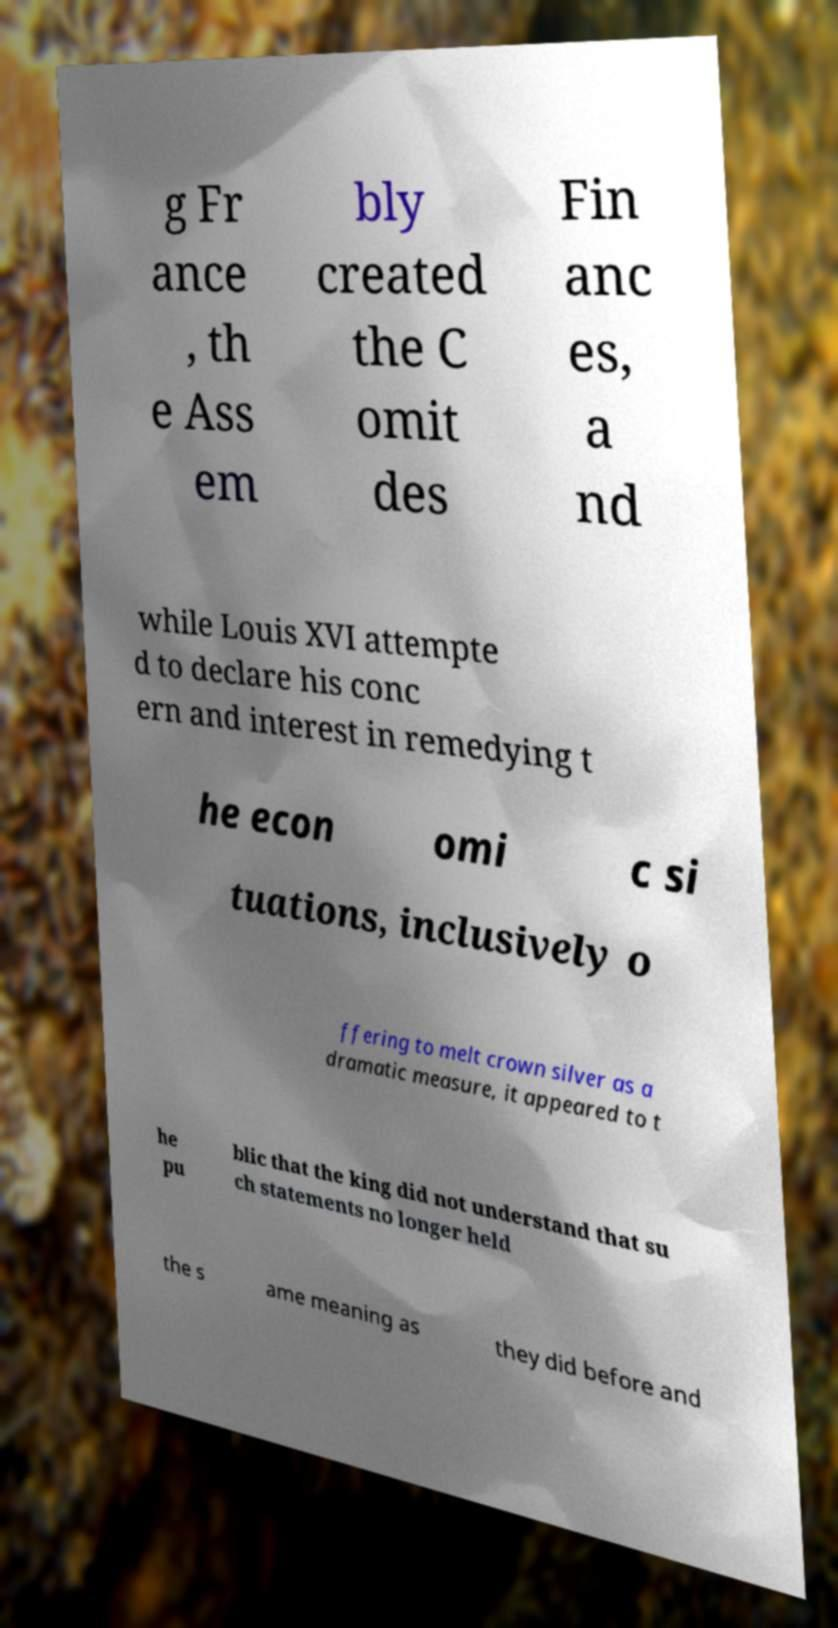Could you assist in decoding the text presented in this image and type it out clearly? g Fr ance , th e Ass em bly created the C omit des Fin anc es, a nd while Louis XVI attempte d to declare his conc ern and interest in remedying t he econ omi c si tuations, inclusively o ffering to melt crown silver as a dramatic measure, it appeared to t he pu blic that the king did not understand that su ch statements no longer held the s ame meaning as they did before and 